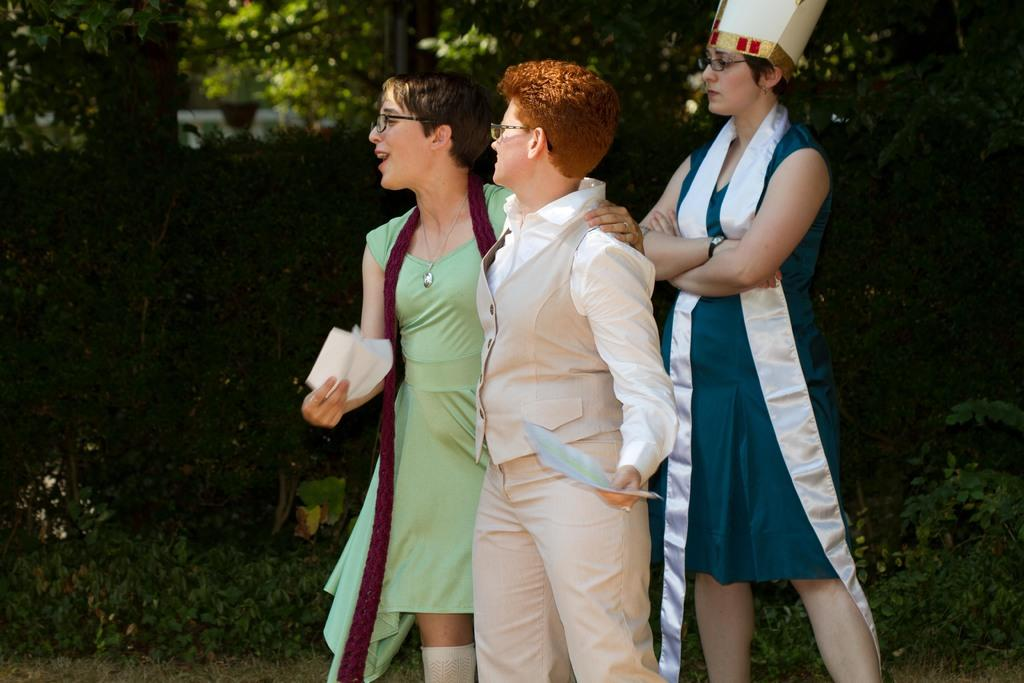What are the people in the image doing? The people in the image are standing on the ground. What can be seen in the background of the image? There are shrubs, bushes, and trees in the background of the image. What type of flag is being waved by the people in the image? There is no flag present in the image; the people are simply standing on the ground. 